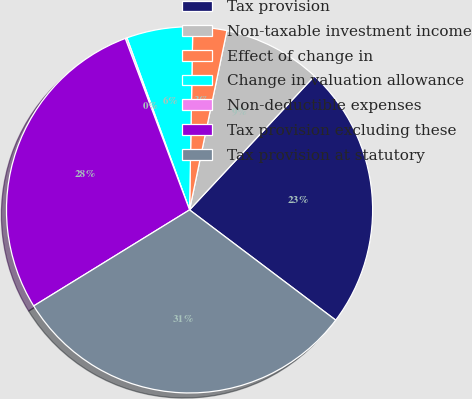<chart> <loc_0><loc_0><loc_500><loc_500><pie_chart><fcel>Tax provision<fcel>Non-taxable investment income<fcel>Effect of change in<fcel>Change in valuation allowance<fcel>Non-deductible expenses<fcel>Tax provision excluding these<fcel>Tax provision at statutory<nl><fcel>23.33%<fcel>8.68%<fcel>2.99%<fcel>5.84%<fcel>0.15%<fcel>28.08%<fcel>30.92%<nl></chart> 